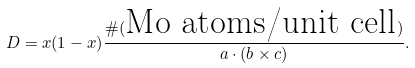<formula> <loc_0><loc_0><loc_500><loc_500>D = x ( 1 - x ) \frac { \# ( \text {Mo atoms/unit cell} ) } { a \cdot ( b \times c ) } .</formula> 